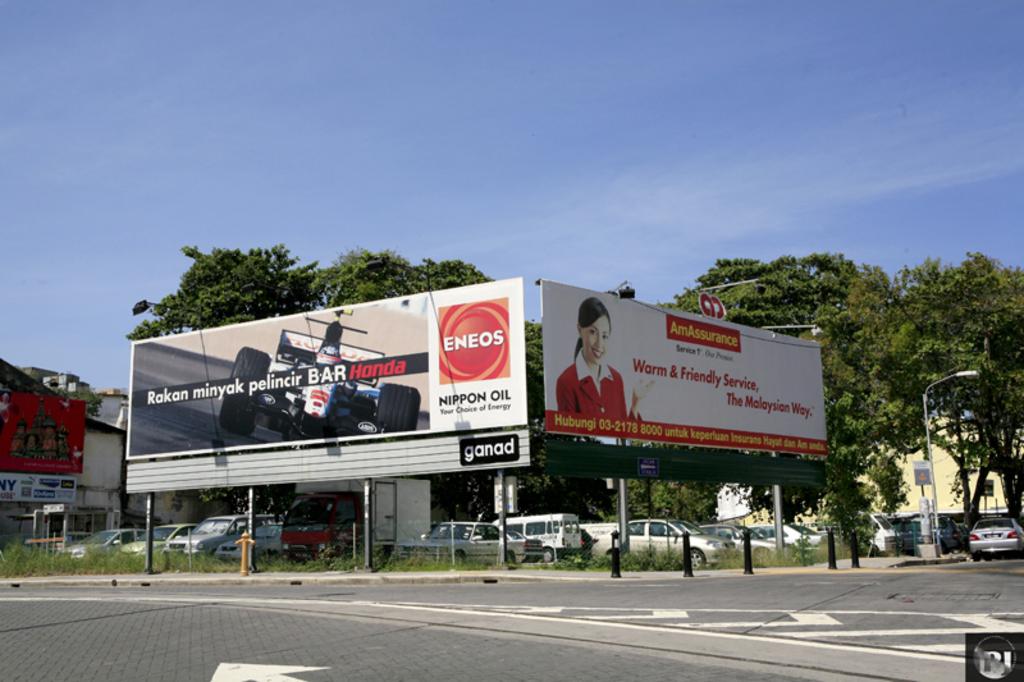What advert is that for?
Offer a terse response. Eneos. 